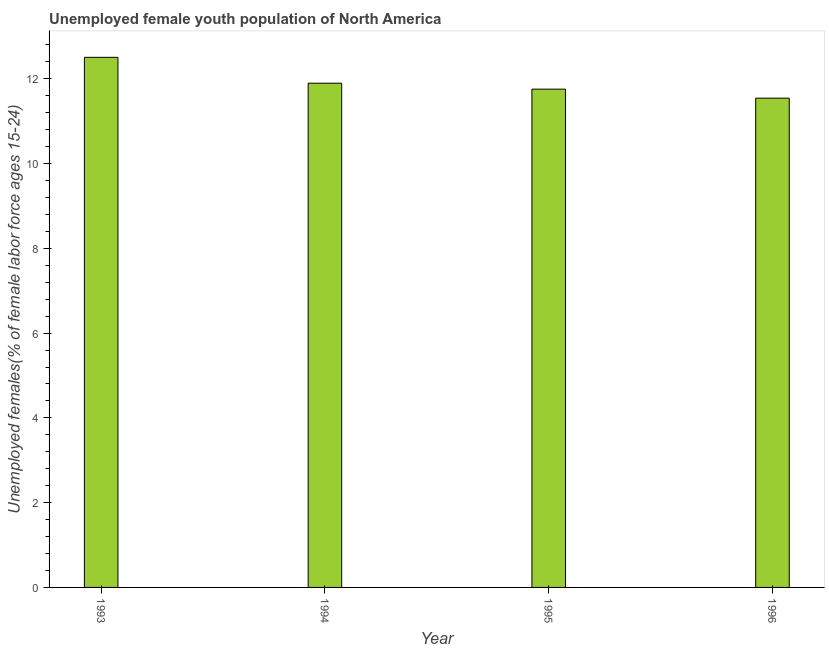Does the graph contain any zero values?
Keep it short and to the point. No. What is the title of the graph?
Make the answer very short. Unemployed female youth population of North America. What is the label or title of the Y-axis?
Provide a short and direct response. Unemployed females(% of female labor force ages 15-24). What is the unemployed female youth in 1995?
Your answer should be compact. 11.76. Across all years, what is the maximum unemployed female youth?
Ensure brevity in your answer.  12.51. Across all years, what is the minimum unemployed female youth?
Provide a succinct answer. 11.54. In which year was the unemployed female youth maximum?
Offer a terse response. 1993. What is the sum of the unemployed female youth?
Make the answer very short. 47.71. What is the difference between the unemployed female youth in 1994 and 1996?
Your answer should be compact. 0.35. What is the average unemployed female youth per year?
Offer a terse response. 11.93. What is the median unemployed female youth?
Keep it short and to the point. 11.83. What is the ratio of the unemployed female youth in 1994 to that in 1996?
Your response must be concise. 1.03. Is the difference between the unemployed female youth in 1994 and 1995 greater than the difference between any two years?
Offer a very short reply. No. What is the difference between the highest and the second highest unemployed female youth?
Your response must be concise. 0.61. Is the sum of the unemployed female youth in 1993 and 1996 greater than the maximum unemployed female youth across all years?
Provide a succinct answer. Yes. In how many years, is the unemployed female youth greater than the average unemployed female youth taken over all years?
Ensure brevity in your answer.  1. How many bars are there?
Provide a succinct answer. 4. What is the Unemployed females(% of female labor force ages 15-24) in 1993?
Provide a succinct answer. 12.51. What is the Unemployed females(% of female labor force ages 15-24) of 1994?
Make the answer very short. 11.9. What is the Unemployed females(% of female labor force ages 15-24) in 1995?
Ensure brevity in your answer.  11.76. What is the Unemployed females(% of female labor force ages 15-24) of 1996?
Provide a succinct answer. 11.54. What is the difference between the Unemployed females(% of female labor force ages 15-24) in 1993 and 1994?
Provide a short and direct response. 0.61. What is the difference between the Unemployed females(% of female labor force ages 15-24) in 1993 and 1995?
Offer a terse response. 0.75. What is the difference between the Unemployed females(% of female labor force ages 15-24) in 1993 and 1996?
Offer a terse response. 0.96. What is the difference between the Unemployed females(% of female labor force ages 15-24) in 1994 and 1995?
Your answer should be very brief. 0.14. What is the difference between the Unemployed females(% of female labor force ages 15-24) in 1994 and 1996?
Keep it short and to the point. 0.35. What is the difference between the Unemployed females(% of female labor force ages 15-24) in 1995 and 1996?
Offer a terse response. 0.21. What is the ratio of the Unemployed females(% of female labor force ages 15-24) in 1993 to that in 1994?
Make the answer very short. 1.05. What is the ratio of the Unemployed females(% of female labor force ages 15-24) in 1993 to that in 1995?
Your answer should be very brief. 1.06. What is the ratio of the Unemployed females(% of female labor force ages 15-24) in 1993 to that in 1996?
Provide a succinct answer. 1.08. What is the ratio of the Unemployed females(% of female labor force ages 15-24) in 1994 to that in 1996?
Offer a terse response. 1.03. What is the ratio of the Unemployed females(% of female labor force ages 15-24) in 1995 to that in 1996?
Provide a short and direct response. 1.02. 